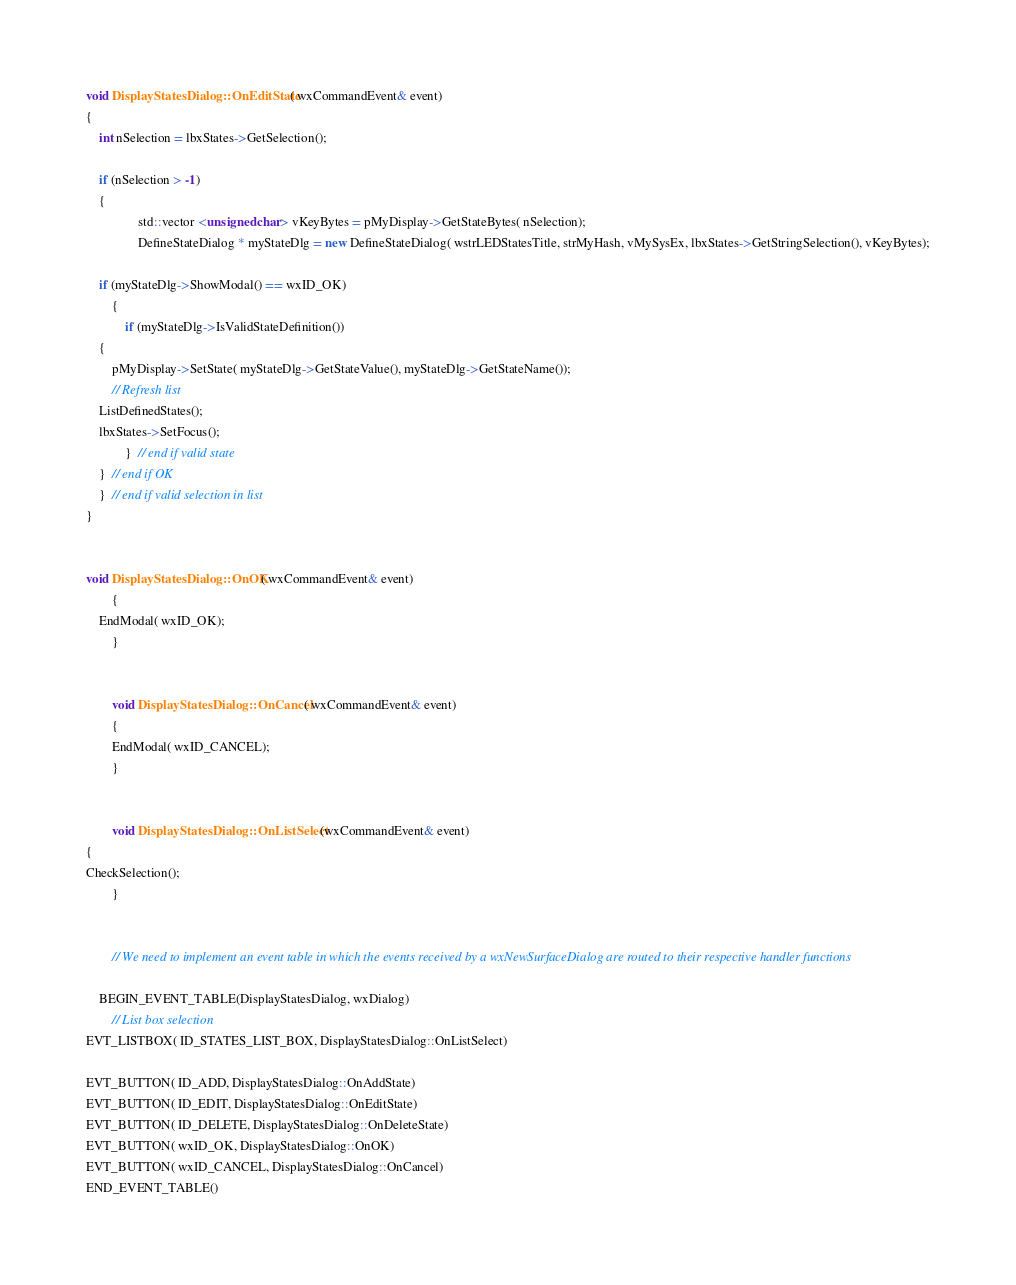<code> <loc_0><loc_0><loc_500><loc_500><_C++_>

void DisplayStatesDialog::OnEditState( wxCommandEvent& event)
{
	int nSelection = lbxStates->GetSelection();

	if (nSelection > -1)
	{
				std::vector <unsigned char> vKeyBytes = pMyDisplay->GetStateBytes( nSelection);
				DefineStateDialog * myStateDlg = new DefineStateDialog( wstrLEDStatesTitle, strMyHash, vMySysEx, lbxStates->GetStringSelection(), vKeyBytes);

	if (myStateDlg->ShowModal() == wxID_OK) 
		{
			if (myStateDlg->IsValidStateDefinition())
	{
		pMyDisplay->SetState( myStateDlg->GetStateValue(), myStateDlg->GetStateName());
		// Refresh list
	ListDefinedStates();
	lbxStates->SetFocus();
			}  // end if valid state
	}  // end if OK
	}  // end if valid selection in list
}


void DisplayStatesDialog::OnOK( wxCommandEvent& event)
		{
	EndModal( wxID_OK);
		}

		
		void DisplayStatesDialog::OnCancel( wxCommandEvent& event)
		{
		EndModal( wxID_CANCEL);
		}

		
		void DisplayStatesDialog::OnListSelect(wxCommandEvent& event)
{
CheckSelection();
		}


		// We need to implement an event table in which the events received by a wxNewSurfaceDialog are routed to their respective handler functions 

	BEGIN_EVENT_TABLE(DisplayStatesDialog, wxDialog)
		// List box selection
EVT_LISTBOX( ID_STATES_LIST_BOX, DisplayStatesDialog::OnListSelect)

EVT_BUTTON( ID_ADD, DisplayStatesDialog::OnAddState)
EVT_BUTTON( ID_EDIT, DisplayStatesDialog::OnEditState)	    
EVT_BUTTON( ID_DELETE, DisplayStatesDialog::OnDeleteState)
EVT_BUTTON( wxID_OK, DisplayStatesDialog::OnOK)
EVT_BUTTON( wxID_CANCEL, DisplayStatesDialog::OnCancel)
END_EVENT_TABLE()
</code> 